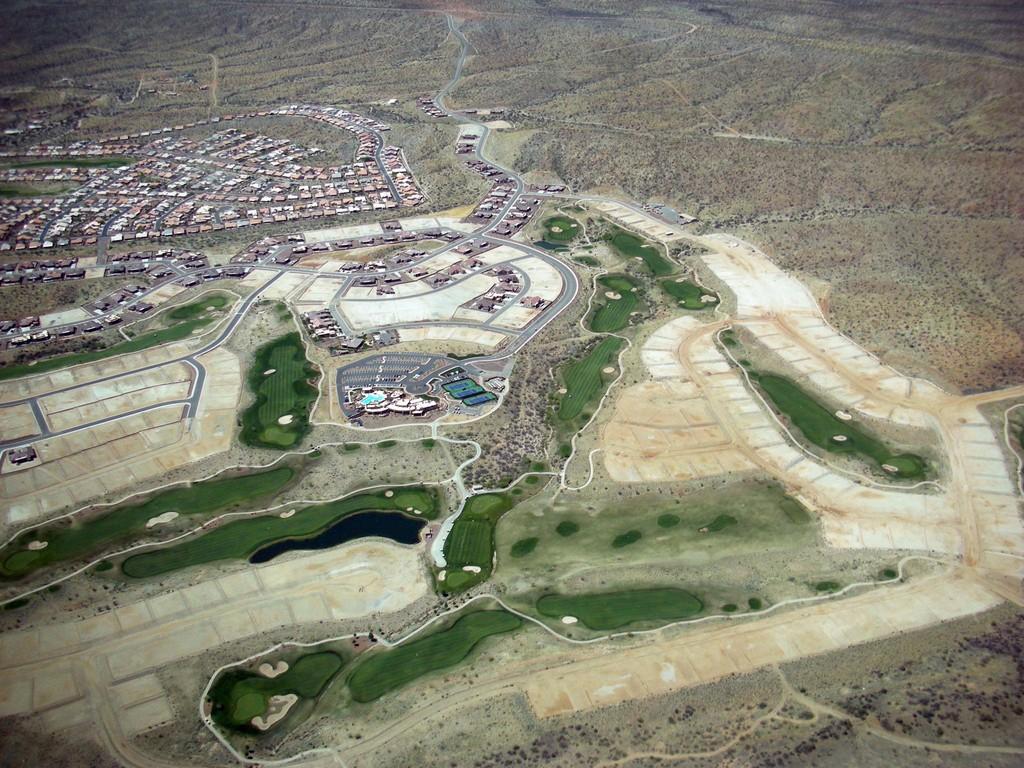Could you give a brief overview of what you see in this image? In this image I can see an aerial view and I can see few buildings, roads and water. 